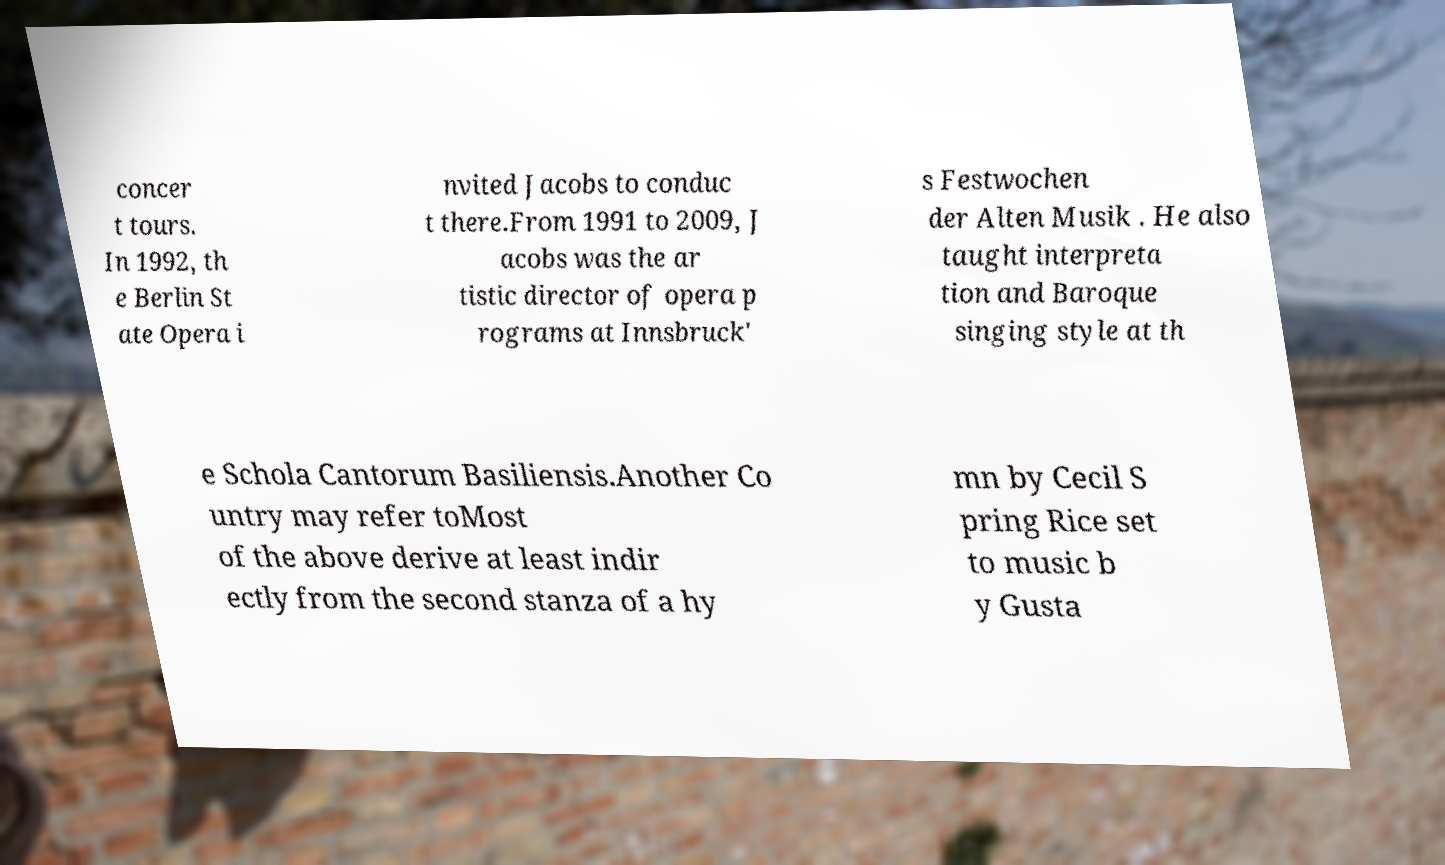Please identify and transcribe the text found in this image. concer t tours. In 1992, th e Berlin St ate Opera i nvited Jacobs to conduc t there.From 1991 to 2009, J acobs was the ar tistic director of opera p rograms at Innsbruck' s Festwochen der Alten Musik . He also taught interpreta tion and Baroque singing style at th e Schola Cantorum Basiliensis.Another Co untry may refer toMost of the above derive at least indir ectly from the second stanza of a hy mn by Cecil S pring Rice set to music b y Gusta 